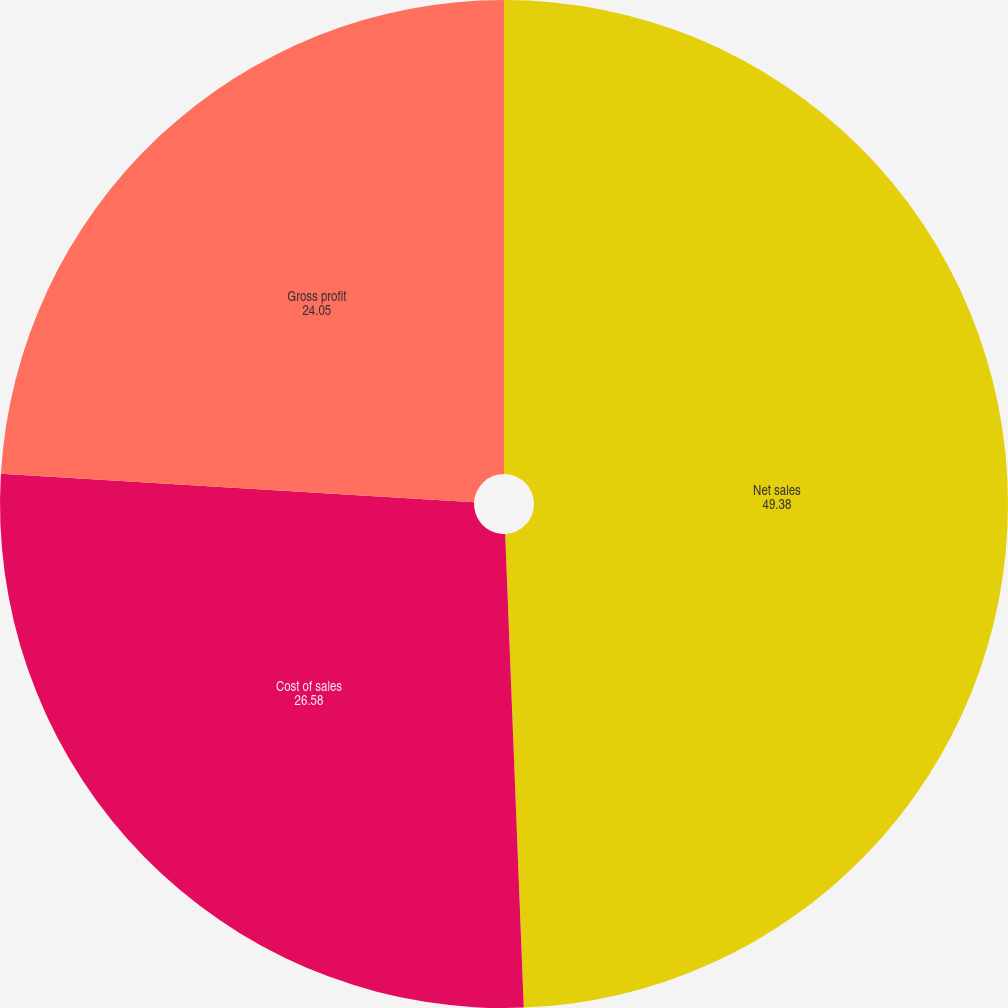<chart> <loc_0><loc_0><loc_500><loc_500><pie_chart><fcel>Net sales<fcel>Cost of sales<fcel>Gross profit<nl><fcel>49.38%<fcel>26.58%<fcel>24.05%<nl></chart> 